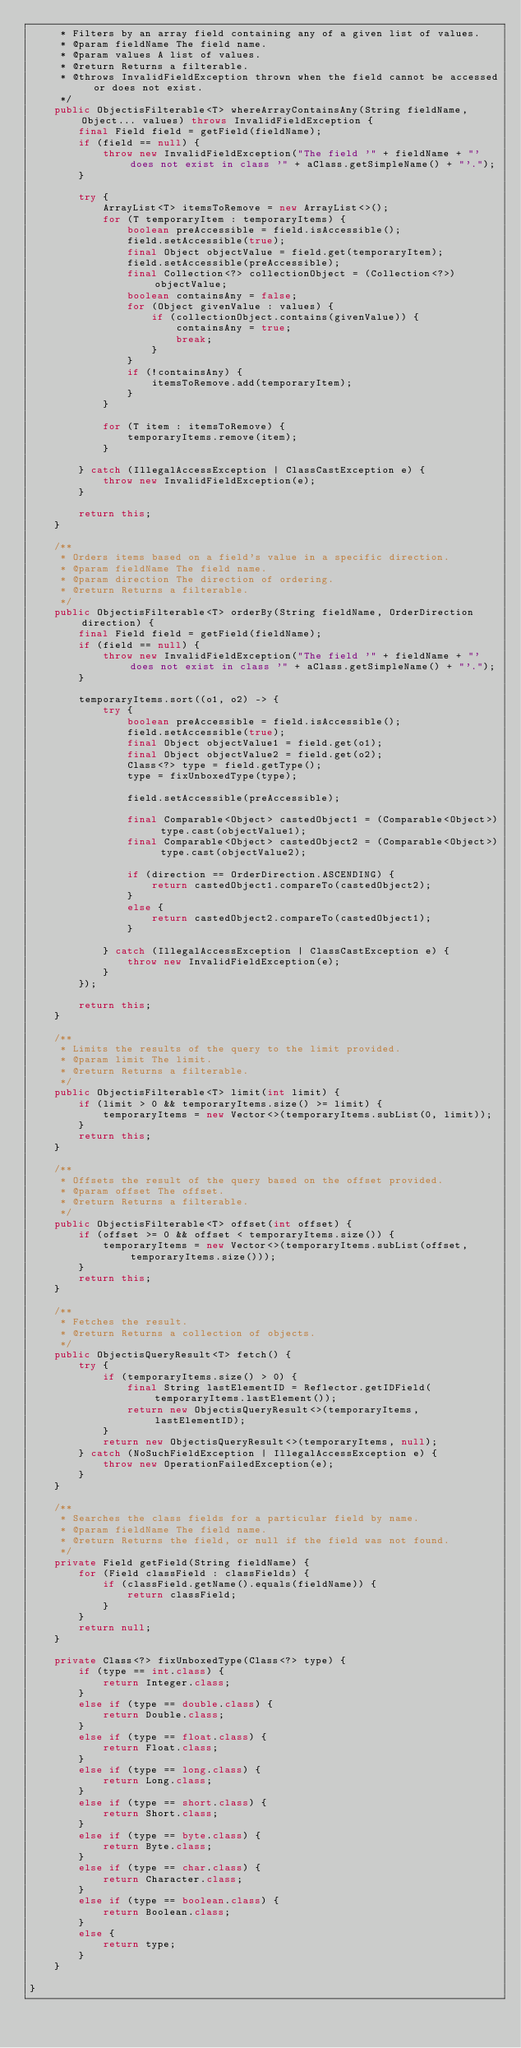<code> <loc_0><loc_0><loc_500><loc_500><_Java_>     * Filters by an array field containing any of a given list of values.
     * @param fieldName The field name.
     * @param values A list of values.
     * @return Returns a filterable.
     * @throws InvalidFieldException thrown when the field cannot be accessed or does not exist.
     */
    public ObjectisFilterable<T> whereArrayContainsAny(String fieldName, Object... values) throws InvalidFieldException {
        final Field field = getField(fieldName);
        if (field == null) {
            throw new InvalidFieldException("The field '" + fieldName + "' does not exist in class '" + aClass.getSimpleName() + "'.");
        }

        try {
            ArrayList<T> itemsToRemove = new ArrayList<>();
            for (T temporaryItem : temporaryItems) {
                boolean preAccessible = field.isAccessible();
                field.setAccessible(true);
                final Object objectValue = field.get(temporaryItem);
                field.setAccessible(preAccessible);
                final Collection<?> collectionObject = (Collection<?>) objectValue;
                boolean containsAny = false;
                for (Object givenValue : values) {
                    if (collectionObject.contains(givenValue)) {
                        containsAny = true;
                        break;
                    }
                }
                if (!containsAny) {
                    itemsToRemove.add(temporaryItem);
                }
            }

            for (T item : itemsToRemove) {
                temporaryItems.remove(item);
            }

        } catch (IllegalAccessException | ClassCastException e) {
            throw new InvalidFieldException(e);
        }

        return this;
    }

    /**
     * Orders items based on a field's value in a specific direction.
     * @param fieldName The field name.
     * @param direction The direction of ordering.
     * @return Returns a filterable.
     */
    public ObjectisFilterable<T> orderBy(String fieldName, OrderDirection direction) {
        final Field field = getField(fieldName);
        if (field == null) {
            throw new InvalidFieldException("The field '" + fieldName + "' does not exist in class '" + aClass.getSimpleName() + "'.");
        }

        temporaryItems.sort((o1, o2) -> {
            try {
                boolean preAccessible = field.isAccessible();
                field.setAccessible(true);
                final Object objectValue1 = field.get(o1);
                final Object objectValue2 = field.get(o2);
                Class<?> type = field.getType();
                type = fixUnboxedType(type);

                field.setAccessible(preAccessible);

                final Comparable<Object> castedObject1 = (Comparable<Object>) type.cast(objectValue1);
                final Comparable<Object> castedObject2 = (Comparable<Object>) type.cast(objectValue2);

                if (direction == OrderDirection.ASCENDING) {
                    return castedObject1.compareTo(castedObject2);
                }
                else {
                    return castedObject2.compareTo(castedObject1);
                }

            } catch (IllegalAccessException | ClassCastException e) {
                throw new InvalidFieldException(e);
            }
        });

        return this;
    }

    /**
     * Limits the results of the query to the limit provided.
     * @param limit The limit.
     * @return Returns a filterable.
     */
    public ObjectisFilterable<T> limit(int limit) {
        if (limit > 0 && temporaryItems.size() >= limit) {
            temporaryItems = new Vector<>(temporaryItems.subList(0, limit));
        }
        return this;
    }

    /**
     * Offsets the result of the query based on the offset provided.
     * @param offset The offset.
     * @return Returns a filterable.
     */
    public ObjectisFilterable<T> offset(int offset) {
        if (offset >= 0 && offset < temporaryItems.size()) {
            temporaryItems = new Vector<>(temporaryItems.subList(offset, temporaryItems.size()));
        }
        return this;
    }

    /**
     * Fetches the result.
     * @return Returns a collection of objects.
     */
    public ObjectisQueryResult<T> fetch() {
        try {
            if (temporaryItems.size() > 0) {
                final String lastElementID = Reflector.getIDField(temporaryItems.lastElement());
                return new ObjectisQueryResult<>(temporaryItems, lastElementID);
            }
            return new ObjectisQueryResult<>(temporaryItems, null);
        } catch (NoSuchFieldException | IllegalAccessException e) {
            throw new OperationFailedException(e);
        }
    }

    /**
     * Searches the class fields for a particular field by name.
     * @param fieldName The field name.
     * @return Returns the field, or null if the field was not found.
     */
    private Field getField(String fieldName) {
        for (Field classField : classFields) {
            if (classField.getName().equals(fieldName)) {
                return classField;
            }
        }
        return null;
    }

    private Class<?> fixUnboxedType(Class<?> type) {
        if (type == int.class) {
            return Integer.class;
        }
        else if (type == double.class) {
            return Double.class;
        }
        else if (type == float.class) {
            return Float.class;
        }
        else if (type == long.class) {
            return Long.class;
        }
        else if (type == short.class) {
            return Short.class;
        }
        else if (type == byte.class) {
            return Byte.class;
        }
        else if (type == char.class) {
            return Character.class;
        }
        else if (type == boolean.class) {
            return Boolean.class;
        }
        else {
            return type;
        }
    }

}
</code> 